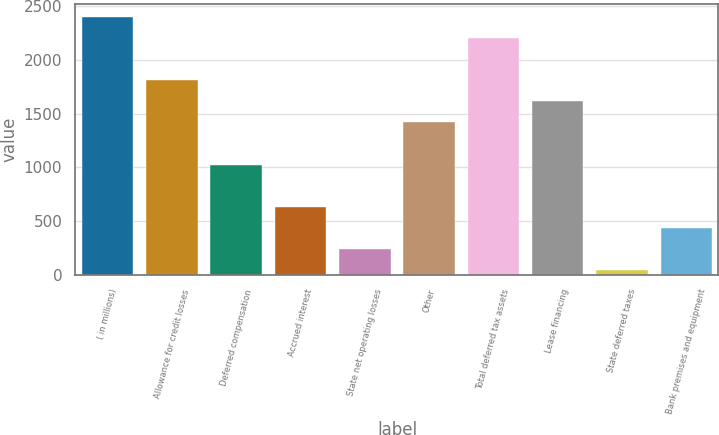Convert chart. <chart><loc_0><loc_0><loc_500><loc_500><bar_chart><fcel>( in millions)<fcel>Allowance for credit losses<fcel>Deferred compensation<fcel>Accrued interest<fcel>State net operating losses<fcel>Other<fcel>Total deferred tax assets<fcel>Lease financing<fcel>State deferred taxes<fcel>Bank premises and equipment<nl><fcel>2400.8<fcel>1811.6<fcel>1026<fcel>633.2<fcel>240.4<fcel>1418.8<fcel>2204.4<fcel>1615.2<fcel>44<fcel>436.8<nl></chart> 